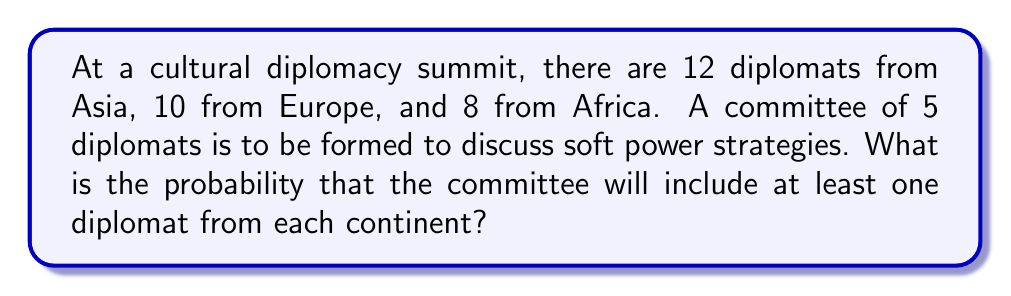What is the answer to this math problem? Let's approach this step-by-step:

1) First, we need to calculate the total number of ways to form a committee of 5 from 30 diplomats:
   $${30 \choose 5} = \frac{30!}{5!(30-5)!} = 142,506$$

2) Now, we need to find the number of ways to form a committee with at least one diplomat from each continent. We can use the Inclusion-Exclusion Principle:

3) Let A be the set of committees with at least one Asian, B with at least one European, and C with at least one African.

4) We want |A ∩ B ∩ C|, which equals:
   $$|A \cup B \cup C| - (|A \cup B| + |A \cup C| + |B \cup C|) + (|A| + |B| + |C|) - |U|$$
   where U is the universal set (all possible committees).

5) Calculate each term:
   - |U| = ${30 \choose 5} = 142,506$
   - |A| = ${12 \choose 1}{18 \choose 4} = 12 \cdot 3060 = 36,720$
   - |B| = ${10 \choose 1}{20 \choose 4} = 10 \cdot 4845 = 48,450$
   - |C| = ${8 \choose 1}{22 \choose 4} = 8 \cdot 7315 = 58,520$
   - |A ∪ B| = ${22 \choose 5} = 26,334$
   - |A ∪ C| = ${20 \choose 5} = 15,504$
   - |B ∪ C| = ${18 \choose 5} = 8,568$
   - |A ∪ B ∪ C| = ${30 \choose 5} = 142,506$

6) Substituting these values:
   $$142,506 - (26,334 + 15,504 + 8,568) + (36,720 + 48,450 + 58,520) - 142,506 = 93,284$$

7) Therefore, the probability is:
   $$\frac{93,284}{142,506} \approx 0.6546$$
Answer: $\frac{93,284}{142,506} \approx 0.6546$ 